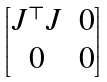Convert formula to latex. <formula><loc_0><loc_0><loc_500><loc_500>\begin{bmatrix} J ^ { \top } J & 0 \\ 0 & 0 \end{bmatrix}</formula> 